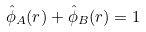Convert formula to latex. <formula><loc_0><loc_0><loc_500><loc_500>\hat { \phi } _ { A } ( { r } ) + \hat { \phi } _ { B } ( { r } ) = 1</formula> 